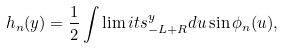<formula> <loc_0><loc_0><loc_500><loc_500>h _ { n } ( y ) = \frac { 1 } { 2 } \int \lim i t s _ { - L + R } ^ { y } d u \sin \phi _ { n } ( u ) ,</formula> 